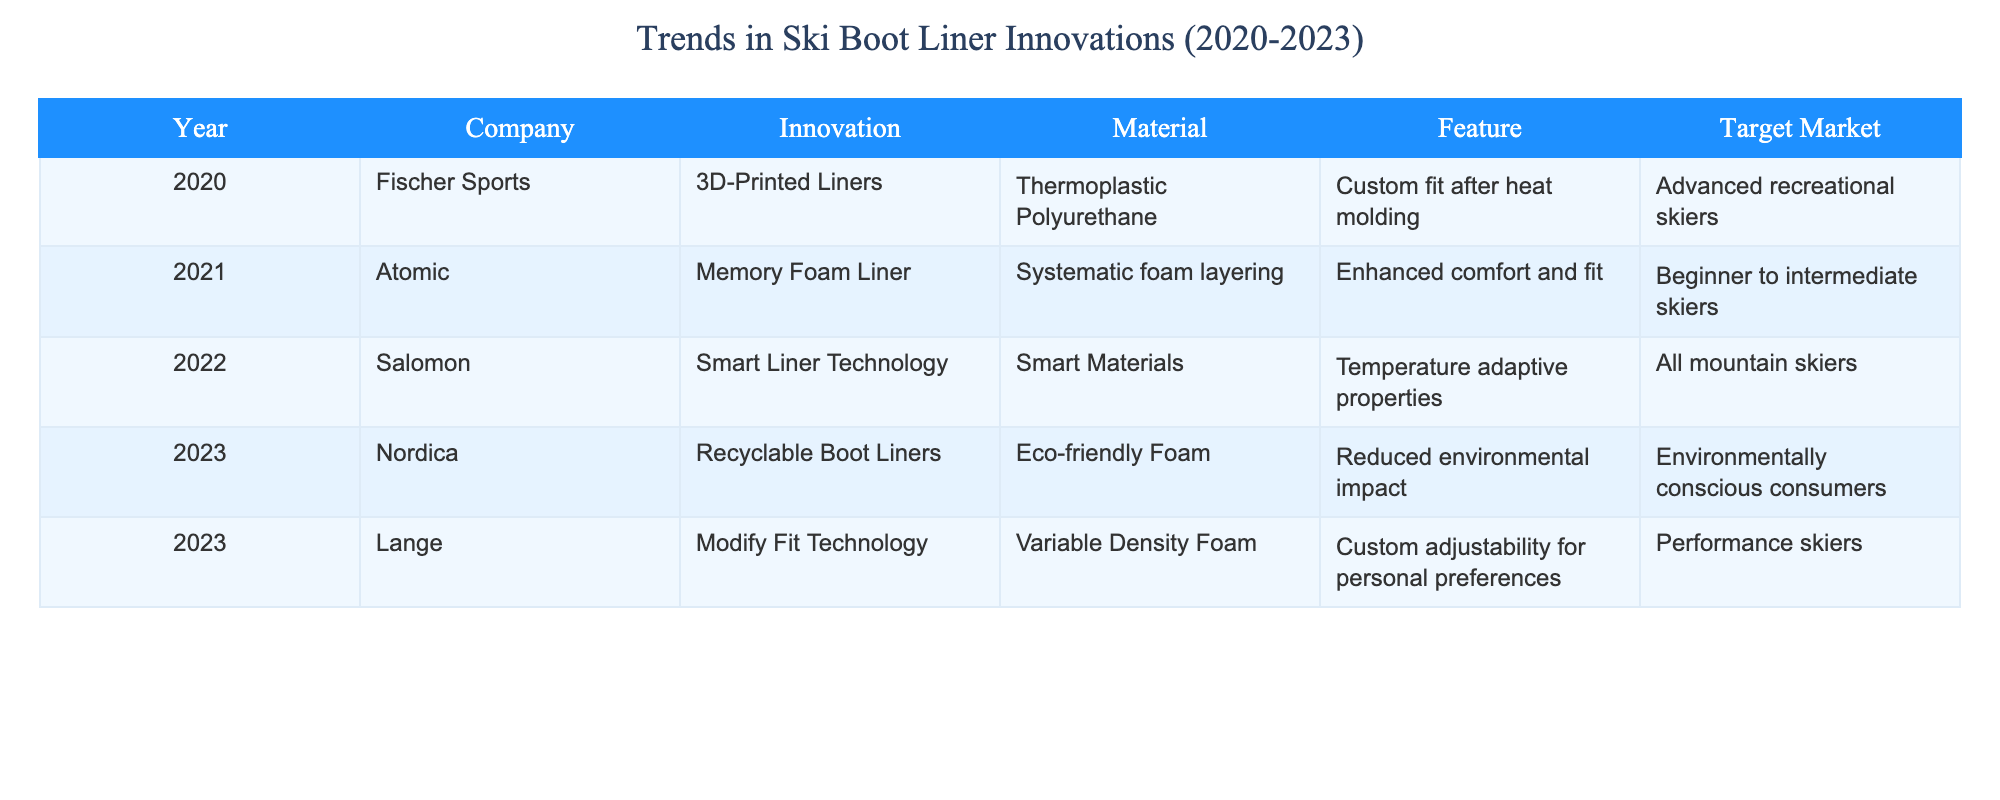What innovation did Fischer Sports introduce in 2020? According to the table, Fischer Sports introduced 3D-Printed Liners in 2020.
Answer: 3D-Printed Liners Which company launched a product focused on temperature adaptive properties in 2022? The table indicates that Salomon launched the Smart Liner Technology that features temperature adaptive properties in 2022.
Answer: Salomon How many companies introduced innovations in 2023? The table shows that two companies, Nordica and Lange, introduced their innovations in 2023.
Answer: Two companies What material was used for the Memory Foam Liner introduced by Atomic? The table lists Systematic foam layering as the material used for the Memory Foam Liner introduced by Atomic in 2021.
Answer: Systematic foam layering Which target market is associated with the Modify Fit Technology from Lange? The table specifies that the Modify Fit Technology from Lange targets performance skiers.
Answer: Performance skiers True or False: Salomon's innovation is aimed at environmentally conscious consumers. From the table, Salomon's Smart Liner Technology is not aimed at environmentally conscious consumers, but at all mountain skiers, making this statement false.
Answer: False What trend can be observed from the innovations listed in 2020 to 2023 regarding environmental concerns? Looking at the table, there is a shift towards eco-friendly technologies as evidenced by Nordica's introduction of recyclable boot liners in 2023, indicating a growing trend in sustainability within the industry.
Answer: Shift towards eco-friendly innovations What is the average target market sophistication level based on the innovation descriptions from 2020 to 2023? Evaluating the target markets: Advanced recreational skiers, beginner to intermediate skiers, all mountain skiers, environmentally conscious consumers, and performance skiers. These markets average out to reflect a range of sophistication levels, but primarily it skews towards the intermediate and advanced users. This indicates a focus on skilled skiers.
Answer: Intermediate to advanced How does the feature of the 2023 Nordica liners compare to the 2020 Fischer liners? The feature of the 2023 Nordica recyclable boot liners (reduced environmental impact) extends the focus beyond performance, whereas the 2020 Fischer liners' feature (custom fit after heat molding) is centered solely on fit and performance, illustrating a shift in focus from performance to sustainability in the industry.
Answer: Focus on sustainability vs. performance 